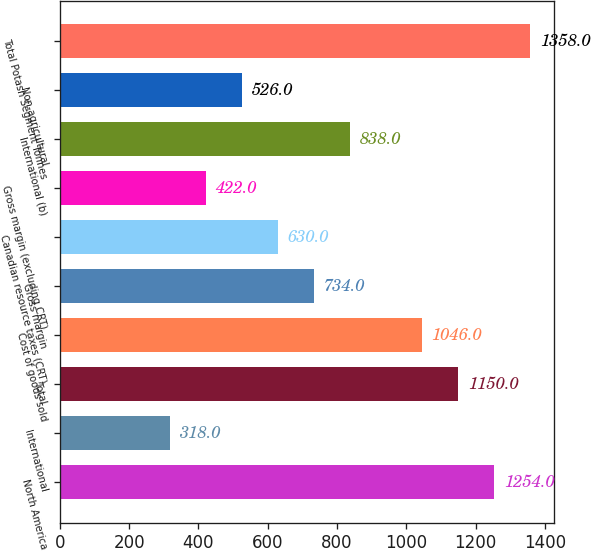Convert chart. <chart><loc_0><loc_0><loc_500><loc_500><bar_chart><fcel>North America<fcel>International<fcel>Total<fcel>Cost of goods sold<fcel>Gross margin<fcel>Canadian resource taxes (CRT)<fcel>Gross margin (excluding CRT)<fcel>International (b)<fcel>Non-agricultural<fcel>Total Potash Segment Tonnes<nl><fcel>1254<fcel>318<fcel>1150<fcel>1046<fcel>734<fcel>630<fcel>422<fcel>838<fcel>526<fcel>1358<nl></chart> 